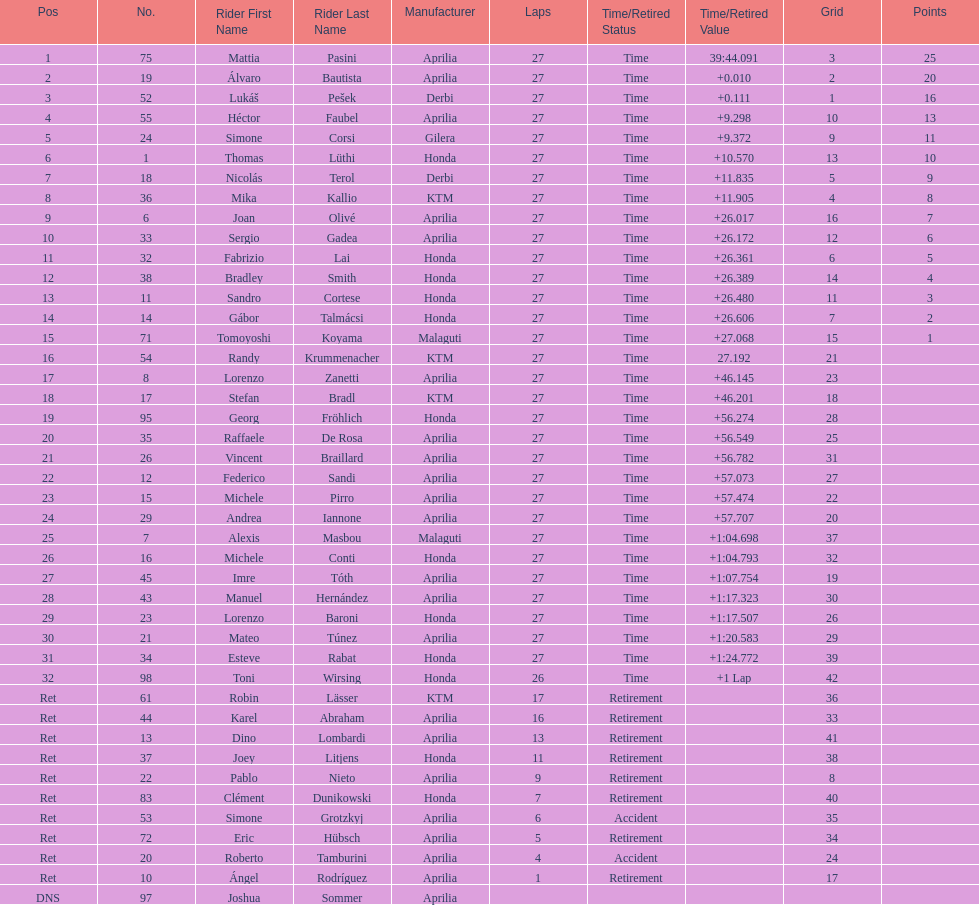Can you parse all the data within this table? {'header': ['Pos', 'No.', 'Rider First Name', 'Rider Last Name', 'Manufacturer', 'Laps', 'Time/Retired Status', 'Time/Retired Value', 'Grid', 'Points'], 'rows': [['1', '75', 'Mattia', 'Pasini', 'Aprilia', '27', 'Time', '39:44.091', '3', '25'], ['2', '19', 'Álvaro', 'Bautista', 'Aprilia', '27', 'Time', '+0.010', '2', '20'], ['3', '52', 'Lukáš', 'Pešek', 'Derbi', '27', 'Time', '+0.111', '1', '16'], ['4', '55', 'Héctor', 'Faubel', 'Aprilia', '27', 'Time', '+9.298', '10', '13'], ['5', '24', 'Simone', 'Corsi', 'Gilera', '27', 'Time', '+9.372', '9', '11'], ['6', '1', 'Thomas', 'Lüthi', 'Honda', '27', 'Time', '+10.570', '13', '10'], ['7', '18', 'Nicolás', 'Terol', 'Derbi', '27', 'Time', '+11.835', '5', '9'], ['8', '36', 'Mika', 'Kallio', 'KTM', '27', 'Time', '+11.905', '4', '8'], ['9', '6', 'Joan', 'Olivé', 'Aprilia', '27', 'Time', '+26.017', '16', '7'], ['10', '33', 'Sergio', 'Gadea', 'Aprilia', '27', 'Time', '+26.172', '12', '6'], ['11', '32', 'Fabrizio', 'Lai', 'Honda', '27', 'Time', '+26.361', '6', '5'], ['12', '38', 'Bradley', 'Smith', 'Honda', '27', 'Time', '+26.389', '14', '4'], ['13', '11', 'Sandro', 'Cortese', 'Honda', '27', 'Time', '+26.480', '11', '3'], ['14', '14', 'Gábor', 'Talmácsi', 'Honda', '27', 'Time', '+26.606', '7', '2'], ['15', '71', 'Tomoyoshi', 'Koyama', 'Malaguti', '27', 'Time', '+27.068', '15', '1'], ['16', '54', 'Randy', 'Krummenacher', 'KTM', '27', 'Time', '27.192', '21', ''], ['17', '8', 'Lorenzo', 'Zanetti', 'Aprilia', '27', 'Time', '+46.145', '23', ''], ['18', '17', 'Stefan', 'Bradl', 'KTM', '27', 'Time', '+46.201', '18', ''], ['19', '95', 'Georg', 'Fröhlich', 'Honda', '27', 'Time', '+56.274', '28', ''], ['20', '35', 'Raffaele', 'De Rosa', 'Aprilia', '27', 'Time', '+56.549', '25', ''], ['21', '26', 'Vincent', 'Braillard', 'Aprilia', '27', 'Time', '+56.782', '31', ''], ['22', '12', 'Federico', 'Sandi', 'Aprilia', '27', 'Time', '+57.073', '27', ''], ['23', '15', 'Michele', 'Pirro', 'Aprilia', '27', 'Time', '+57.474', '22', ''], ['24', '29', 'Andrea', 'Iannone', 'Aprilia', '27', 'Time', '+57.707', '20', ''], ['25', '7', 'Alexis', 'Masbou', 'Malaguti', '27', 'Time', '+1:04.698', '37', ''], ['26', '16', 'Michele', 'Conti', 'Honda', '27', 'Time', '+1:04.793', '32', ''], ['27', '45', 'Imre', 'Tóth', 'Aprilia', '27', 'Time', '+1:07.754', '19', ''], ['28', '43', 'Manuel', 'Hernández', 'Aprilia', '27', 'Time', '+1:17.323', '30', ''], ['29', '23', 'Lorenzo', 'Baroni', 'Honda', '27', 'Time', '+1:17.507', '26', ''], ['30', '21', 'Mateo', 'Túnez', 'Aprilia', '27', 'Time', '+1:20.583', '29', ''], ['31', '34', 'Esteve', 'Rabat', 'Honda', '27', 'Time', '+1:24.772', '39', ''], ['32', '98', 'Toni', 'Wirsing', 'Honda', '26', 'Time', '+1 Lap', '42', ''], ['Ret', '61', 'Robin', 'Lässer', 'KTM', '17', 'Retirement', '', '36', ''], ['Ret', '44', 'Karel', 'Abraham', 'Aprilia', '16', 'Retirement', '', '33', ''], ['Ret', '13', 'Dino', 'Lombardi', 'Aprilia', '13', 'Retirement', '', '41', ''], ['Ret', '37', 'Joey', 'Litjens', 'Honda', '11', 'Retirement', '', '38', ''], ['Ret', '22', 'Pablo', 'Nieto', 'Aprilia', '9', 'Retirement', '', '8', ''], ['Ret', '83', 'Clément', 'Dunikowski', 'Honda', '7', 'Retirement', '', '40', ''], ['Ret', '53', 'Simone', 'Grotzkyj', 'Aprilia', '6', 'Accident', '', '35', ''], ['Ret', '72', 'Eric', 'Hübsch', 'Aprilia', '5', 'Retirement', '', '34', ''], ['Ret', '20', 'Roberto', 'Tamburini', 'Aprilia', '4', 'Accident', '', '24', ''], ['Ret', '10', 'Ángel', 'Rodríguez', 'Aprilia', '1', 'Retirement', '', '17', ''], ['DNS', '97', 'Joshua', 'Sommer', 'Aprilia', '', '', '', '', '']]} Who placed higher, bradl or gadea? Sergio Gadea. 